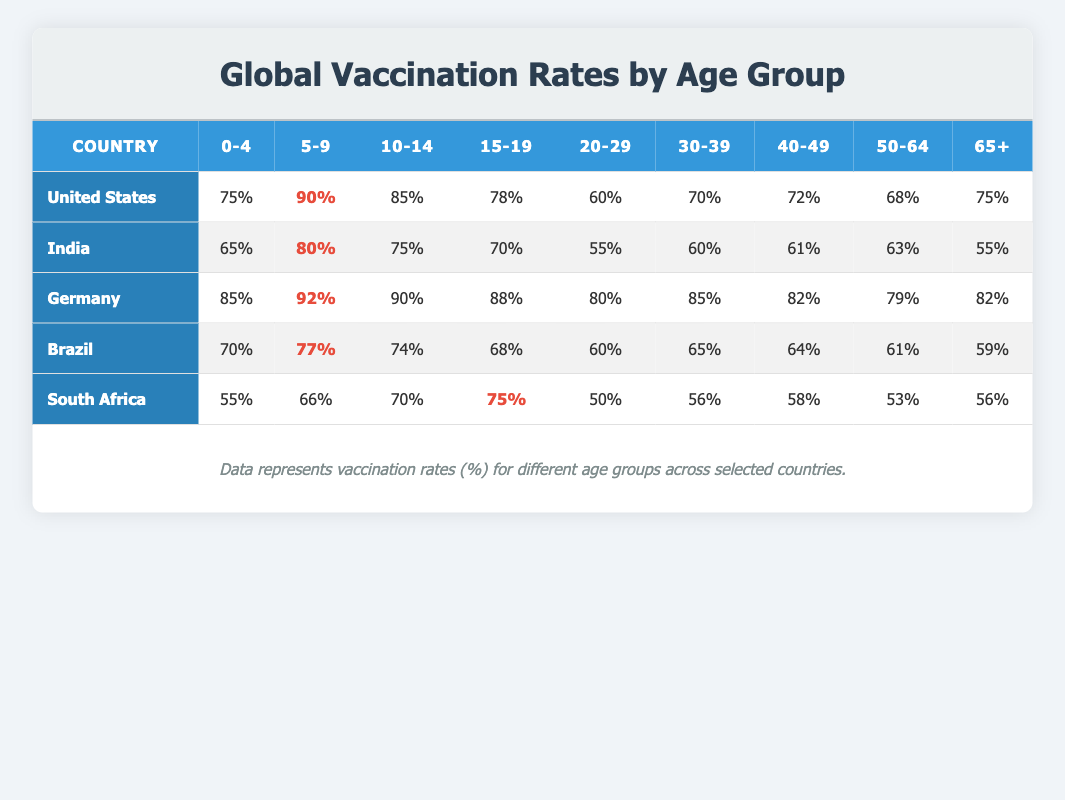What is the vaccination rate for children aged 0-4 in Germany? The table shows that Germany has a vaccination rate of 85% for children aged 0-4.
Answer: 85% Which country has the highest vaccination rate for the age group 5-9? By comparing the rates for the age group 5-9, we see that Germany has the highest rate of 92%.
Answer: Germany What is the average vaccination rate for the 20-29 age group across all countries? The rates for the 20-29 age group are as follows: United States (60%), India (55%), Germany (80%), Brazil (60%), South Africa (50%). The average is calculated as (60 + 55 + 80 + 60 + 50) / 5 = 61.
Answer: 61% Is the vaccination rate for children aged 10-14 higher in the United States compared to South Africa? The vaccination rate for children aged 10-14 is 85% in the United States and 70% in South Africa. Since 85% is greater than 70%, the statement is true.
Answer: Yes What is the difference in vaccination rates between adults aged 50-64 in India and Brazil? The vaccination rate for adults aged 50-64 in India is 63% and in Brazil is 61%. The difference is 63 - 61 = 2%.
Answer: 2% Which age group has the lowest vaccination rate in South Africa? Looking at the age groups in South Africa, the lowest rate is for the 20-29 age group at 50%.
Answer: 50% What is the combined vaccination rate for the age group 30-39 in the United States and Germany? The vaccination rates for the 30-39 age group are 70% in the United States and 85% in Germany. When combined, they total 70 + 85 = 155%.
Answer: 155% Are vaccination rates for the 65+ age group the same in India and South Africa? In the table, India's rate for the 65+ age group is 55% while South Africa's is 56%. Since these percentages differ, the statement is false.
Answer: No What is the median vaccination rate for the age group 15-19 across all countries? The vaccination rates for the 15-19 age group are: United States (78%), India (70%), Germany (88%), Brazil (68%), South Africa (75%). Arranging these rates in order: 68%, 70%, 75%, 78%, 88%. The median, which is the middle value, is 75%.
Answer: 75% 